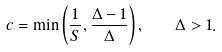<formula> <loc_0><loc_0><loc_500><loc_500>c = \min \left ( \frac { 1 } { S } , \frac { \Delta - 1 } \Delta \right ) , \quad \Delta > 1 .</formula> 